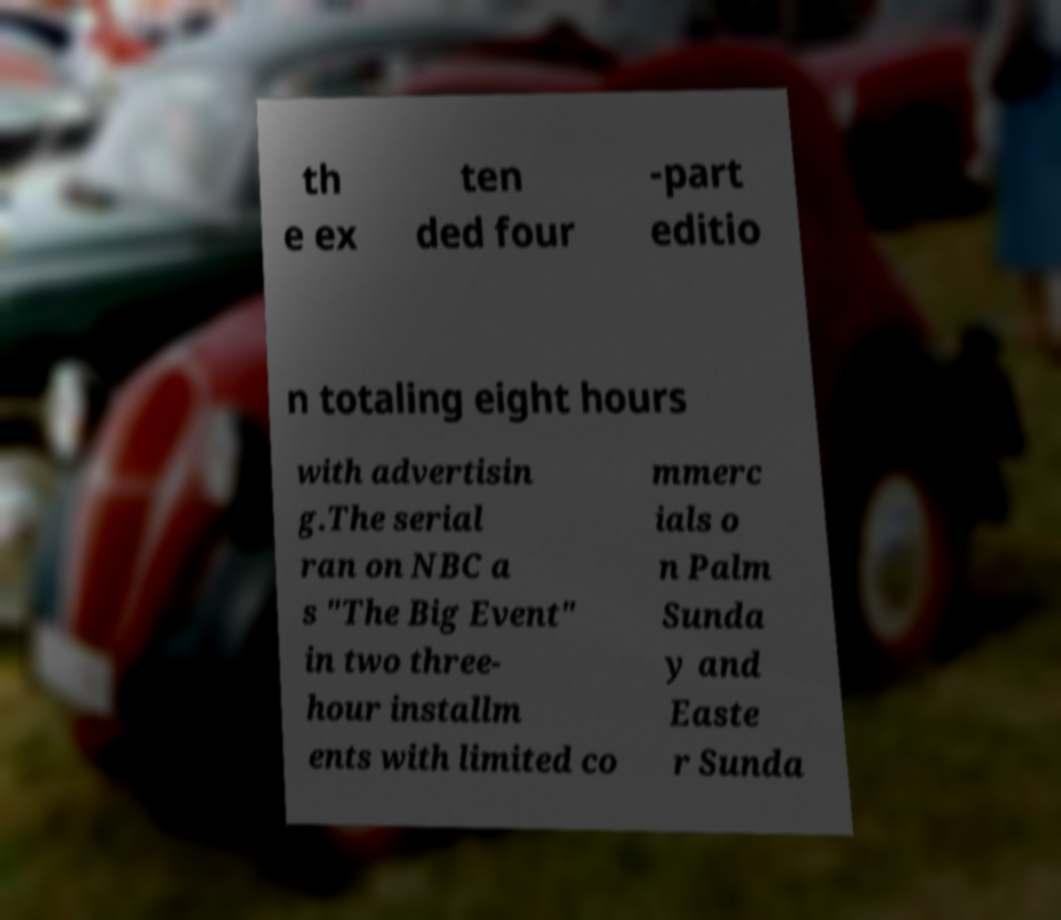There's text embedded in this image that I need extracted. Can you transcribe it verbatim? th e ex ten ded four -part editio n totaling eight hours with advertisin g.The serial ran on NBC a s "The Big Event" in two three- hour installm ents with limited co mmerc ials o n Palm Sunda y and Easte r Sunda 